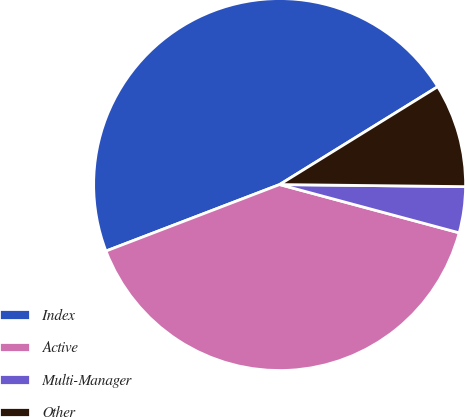Convert chart to OTSL. <chart><loc_0><loc_0><loc_500><loc_500><pie_chart><fcel>Index<fcel>Active<fcel>Multi-Manager<fcel>Other<nl><fcel>47.0%<fcel>40.0%<fcel>4.0%<fcel>9.0%<nl></chart> 